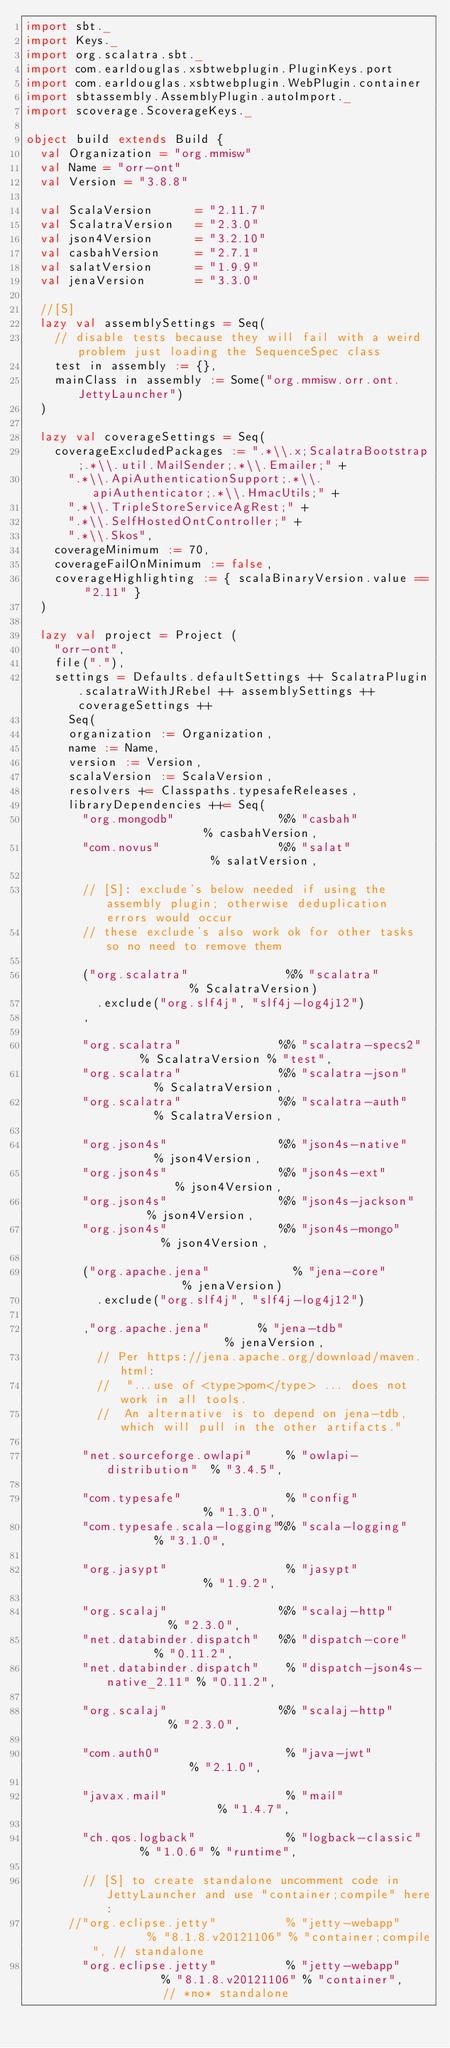Convert code to text. <code><loc_0><loc_0><loc_500><loc_500><_Scala_>import sbt._
import Keys._
import org.scalatra.sbt._
import com.earldouglas.xsbtwebplugin.PluginKeys.port
import com.earldouglas.xsbtwebplugin.WebPlugin.container
import sbtassembly.AssemblyPlugin.autoImport._
import scoverage.ScoverageKeys._

object build extends Build {
  val Organization = "org.mmisw"
  val Name = "orr-ont"
  val Version = "3.8.8"

  val ScalaVersion      = "2.11.7"
  val ScalatraVersion   = "2.3.0"
  val json4Version      = "3.2.10"
  val casbahVersion     = "2.7.1"
  val salatVersion      = "1.9.9"
  val jenaVersion       = "3.3.0"

  //[S]
  lazy val assemblySettings = Seq(
    // disable tests because they will fail with a weird problem just loading the SequenceSpec class
    test in assembly := {},
    mainClass in assembly := Some("org.mmisw.orr.ont.JettyLauncher")
  )

  lazy val coverageSettings = Seq(
    coverageExcludedPackages := ".*\\.x;ScalatraBootstrap;.*\\.util.MailSender;.*\\.Emailer;" +
      ".*\\.ApiAuthenticationSupport;.*\\.apiAuthenticator;.*\\.HmacUtils;" +
      ".*\\.TripleStoreServiceAgRest;" +
      ".*\\.SelfHostedOntController;" +
      ".*\\.Skos",
    coverageMinimum := 70,
    coverageFailOnMinimum := false,
    coverageHighlighting := { scalaBinaryVersion.value == "2.11" }
  )

  lazy val project = Project (
    "orr-ont",
    file("."),
    settings = Defaults.defaultSettings ++ ScalatraPlugin.scalatraWithJRebel ++ assemblySettings ++ coverageSettings ++
      Seq(
      organization := Organization,
      name := Name,
      version := Version,
      scalaVersion := ScalaVersion,
      resolvers += Classpaths.typesafeReleases,
      libraryDependencies ++= Seq(
        "org.mongodb"               %% "casbah"               % casbahVersion,
        "com.novus"                 %% "salat"                % salatVersion,

        // [S]: exclude's below needed if using the assembly plugin; otherwise deduplication errors would occur
        // these exclude's also work ok for other tasks so no need to remove them

        ("org.scalatra"              %% "scalatra"             % ScalatraVersion)
          .exclude("org.slf4j", "slf4j-log4j12")
        ,

        "org.scalatra"              %% "scalatra-specs2"      % ScalatraVersion % "test",
        "org.scalatra"              %% "scalatra-json"        % ScalatraVersion,
        "org.scalatra"              %% "scalatra-auth"        % ScalatraVersion,

        "org.json4s"                %% "json4s-native"        % json4Version,
        "org.json4s"                %% "json4s-ext"           % json4Version,
        "org.json4s"                %% "json4s-jackson"       % json4Version,
        "org.json4s"                %% "json4s-mongo"         % json4Version,

        ("org.apache.jena"            % "jena-core"            % jenaVersion)
          .exclude("org.slf4j", "slf4j-log4j12")

        ,"org.apache.jena"       % "jena-tdb"                  % jenaVersion,
          // Per https://jena.apache.org/download/maven.html:
          //  "...use of <type>pom</type> ... does not work in all tools.
          //  An alternative is to depend on jena-tdb, which will pull in the other artifacts."

        "net.sourceforge.owlapi"     % "owlapi-distribution"  % "3.4.5",

        "com.typesafe"               % "config"               % "1.3.0",
        "com.typesafe.scala-logging"%% "scala-logging"        % "3.1.0",

        "org.jasypt"                 % "jasypt"               % "1.9.2",

        "org.scalaj"                %% "scalaj-http"          % "2.3.0",
        "net.databinder.dispatch"   %% "dispatch-core"        % "0.11.2",
        "net.databinder.dispatch"    % "dispatch-json4s-native_2.11" % "0.11.2",

        "org.scalaj"                %% "scalaj-http"          % "2.3.0",

        "com.auth0"                  % "java-jwt"             % "2.1.0",

        "javax.mail"                 % "mail"                 % "1.4.7",

        "ch.qos.logback"             % "logback-classic"      % "1.0.6" % "runtime",

        // [S] to create standalone uncomment code in JettyLauncher and use "container;compile" here:
      //"org.eclipse.jetty"          % "jetty-webapp"         % "8.1.8.v20121106" % "container;compile", // standalone
        "org.eclipse.jetty"          % "jetty-webapp"         % "8.1.8.v20121106" % "container",         // *no* standalone
</code> 